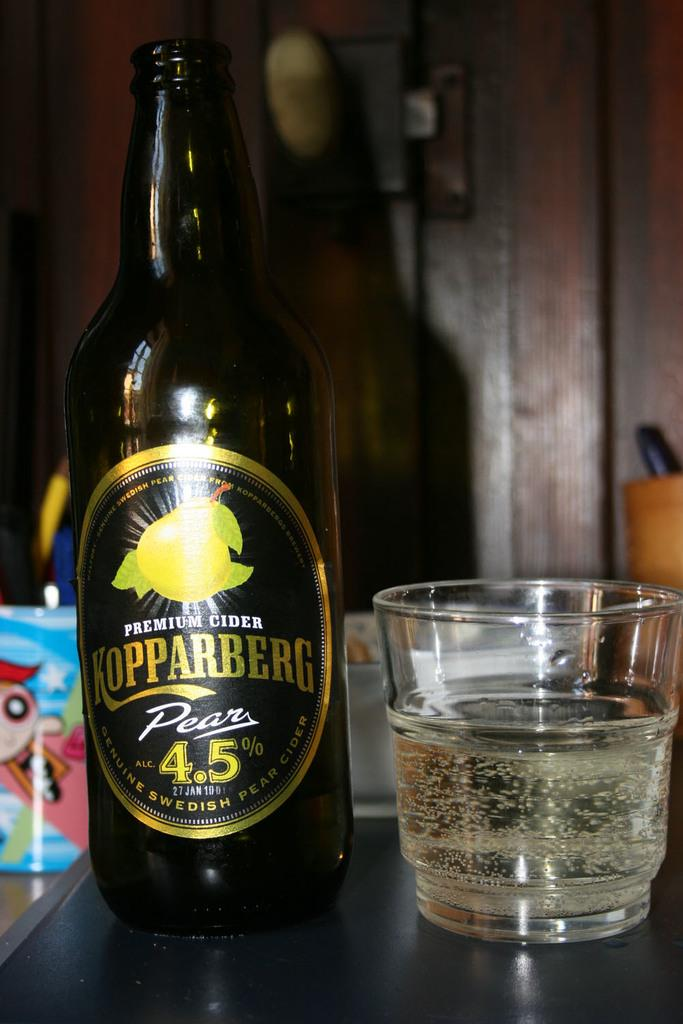<image>
Share a concise interpretation of the image provided. A bottle of Koppaberg Pear beer has been poured into a glass 